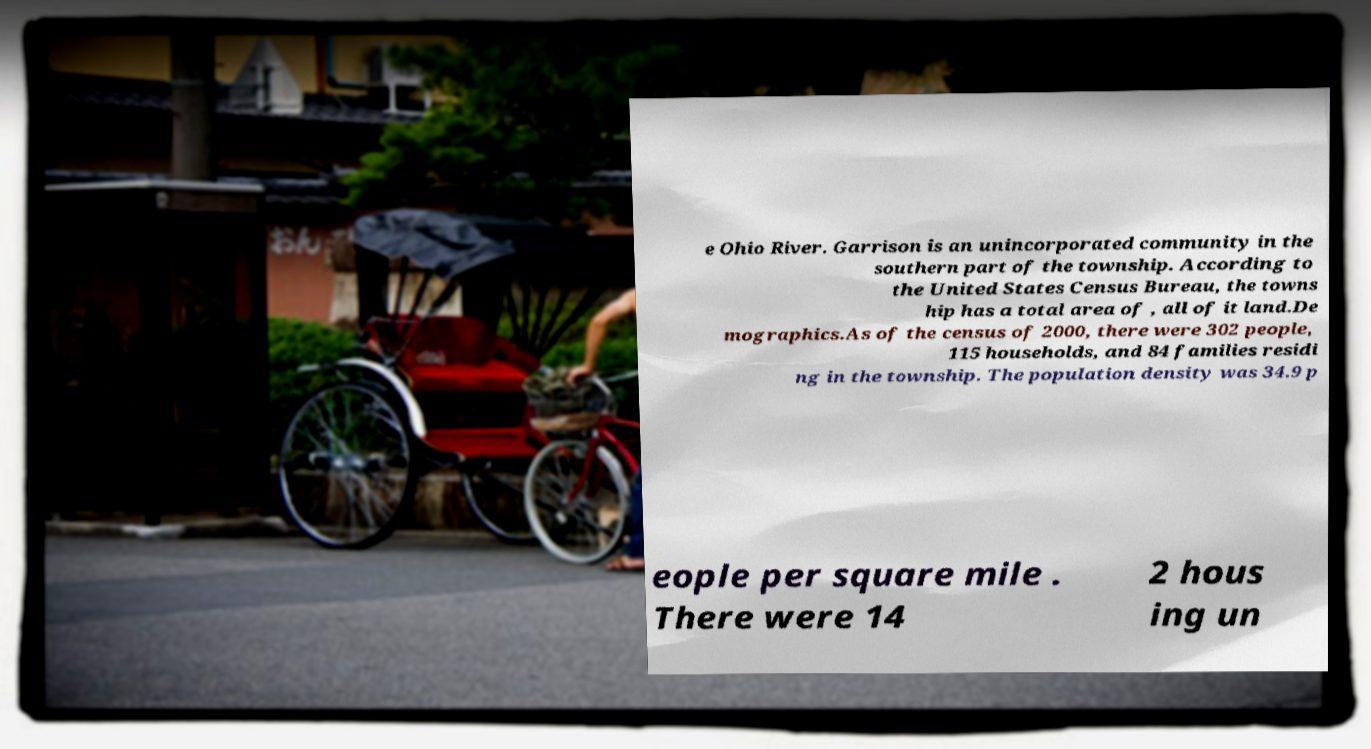For documentation purposes, I need the text within this image transcribed. Could you provide that? e Ohio River. Garrison is an unincorporated community in the southern part of the township. According to the United States Census Bureau, the towns hip has a total area of , all of it land.De mographics.As of the census of 2000, there were 302 people, 115 households, and 84 families residi ng in the township. The population density was 34.9 p eople per square mile . There were 14 2 hous ing un 